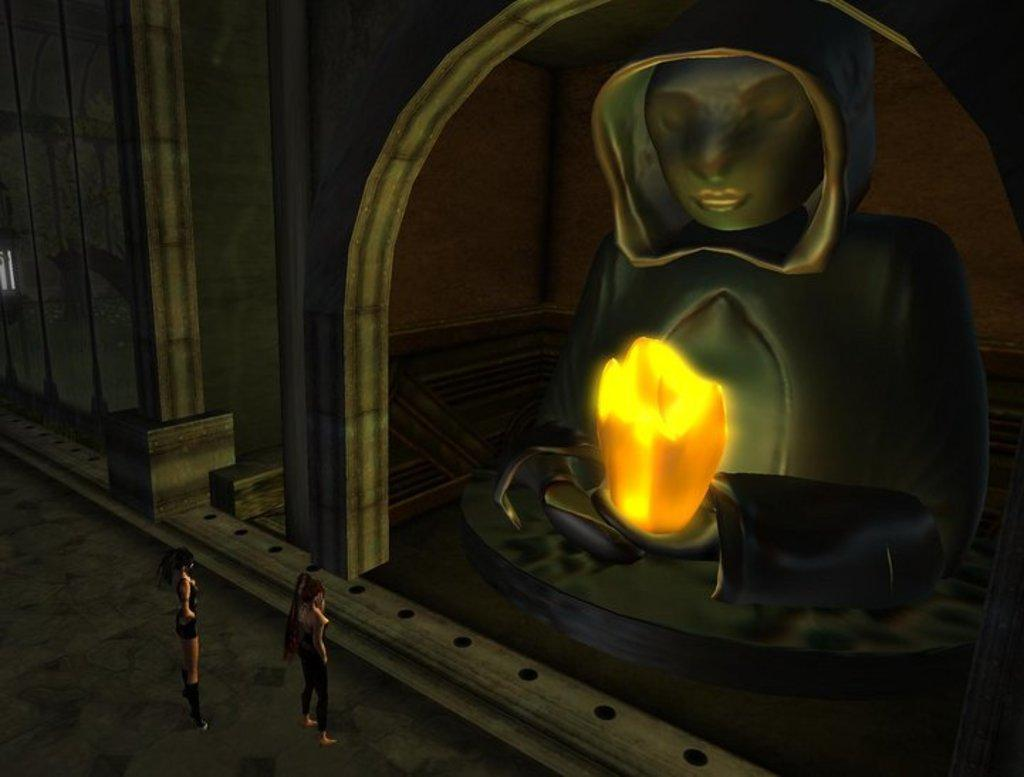How many people are in the image? There are persons in the image, but the exact number is not specified. What is another structure visible in the image besides the persons? There is a statue in the image. What other architectural elements can be seen in the image? There is a pillar and an arch in the image. What type of dog is sitting next to the sister in the image? There is no dog or sister present in the image. What thrilling activity are the persons engaged in within the image? The image does not depict any specific activity or thrilling event. 